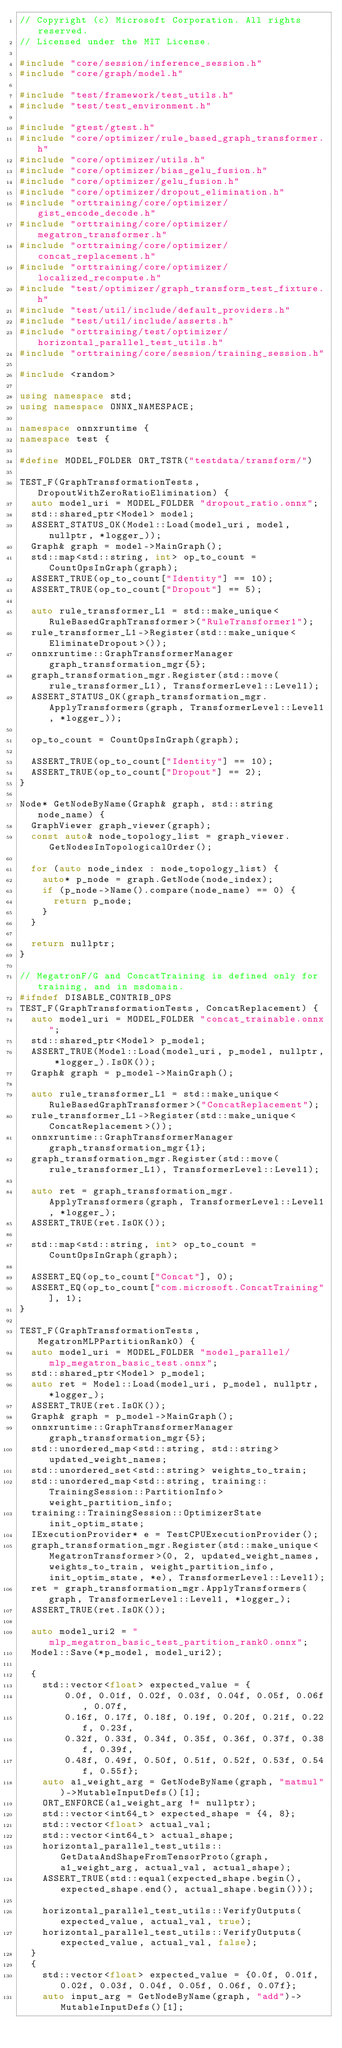<code> <loc_0><loc_0><loc_500><loc_500><_C++_>// Copyright (c) Microsoft Corporation. All rights reserved.
// Licensed under the MIT License.

#include "core/session/inference_session.h"
#include "core/graph/model.h"

#include "test/framework/test_utils.h"
#include "test/test_environment.h"

#include "gtest/gtest.h"
#include "core/optimizer/rule_based_graph_transformer.h"
#include "core/optimizer/utils.h"
#include "core/optimizer/bias_gelu_fusion.h"
#include "core/optimizer/gelu_fusion.h"
#include "core/optimizer/dropout_elimination.h"
#include "orttraining/core/optimizer/gist_encode_decode.h"
#include "orttraining/core/optimizer/megatron_transformer.h"
#include "orttraining/core/optimizer/concat_replacement.h"
#include "orttraining/core/optimizer/localized_recompute.h"
#include "test/optimizer/graph_transform_test_fixture.h"
#include "test/util/include/default_providers.h"
#include "test/util/include/asserts.h"
#include "orttraining/test/optimizer/horizontal_parallel_test_utils.h"
#include "orttraining/core/session/training_session.h"

#include <random>

using namespace std;
using namespace ONNX_NAMESPACE;

namespace onnxruntime {
namespace test {

#define MODEL_FOLDER ORT_TSTR("testdata/transform/")

TEST_F(GraphTransformationTests, DropoutWithZeroRatioElimination) {
  auto model_uri = MODEL_FOLDER "dropout_ratio.onnx";
  std::shared_ptr<Model> model;
  ASSERT_STATUS_OK(Model::Load(model_uri, model, nullptr, *logger_));
  Graph& graph = model->MainGraph();
  std::map<std::string, int> op_to_count = CountOpsInGraph(graph);
  ASSERT_TRUE(op_to_count["Identity"] == 10);
  ASSERT_TRUE(op_to_count["Dropout"] == 5);

  auto rule_transformer_L1 = std::make_unique<RuleBasedGraphTransformer>("RuleTransformer1");
  rule_transformer_L1->Register(std::make_unique<EliminateDropout>());
  onnxruntime::GraphTransformerManager graph_transformation_mgr{5};
  graph_transformation_mgr.Register(std::move(rule_transformer_L1), TransformerLevel::Level1);
  ASSERT_STATUS_OK(graph_transformation_mgr.ApplyTransformers(graph, TransformerLevel::Level1, *logger_));

  op_to_count = CountOpsInGraph(graph);

  ASSERT_TRUE(op_to_count["Identity"] == 10);
  ASSERT_TRUE(op_to_count["Dropout"] == 2);
}

Node* GetNodeByName(Graph& graph, std::string node_name) {
  GraphViewer graph_viewer(graph);
  const auto& node_topology_list = graph_viewer.GetNodesInTopologicalOrder();

  for (auto node_index : node_topology_list) {
    auto* p_node = graph.GetNode(node_index);
    if (p_node->Name().compare(node_name) == 0) {
      return p_node;
    }
  }

  return nullptr;
}

// MegatronF/G and ConcatTraining is defined only for training, and in msdomain.
#ifndef DISABLE_CONTRIB_OPS
TEST_F(GraphTransformationTests, ConcatReplacement) {
  auto model_uri = MODEL_FOLDER "concat_trainable.onnx";
  std::shared_ptr<Model> p_model;
  ASSERT_TRUE(Model::Load(model_uri, p_model, nullptr, *logger_).IsOK());
  Graph& graph = p_model->MainGraph();

  auto rule_transformer_L1 = std::make_unique<RuleBasedGraphTransformer>("ConcatReplacement");
  rule_transformer_L1->Register(std::make_unique<ConcatReplacement>());
  onnxruntime::GraphTransformerManager graph_transformation_mgr{1};
  graph_transformation_mgr.Register(std::move(rule_transformer_L1), TransformerLevel::Level1);

  auto ret = graph_transformation_mgr.ApplyTransformers(graph, TransformerLevel::Level1, *logger_);
  ASSERT_TRUE(ret.IsOK());

  std::map<std::string, int> op_to_count = CountOpsInGraph(graph);

  ASSERT_EQ(op_to_count["Concat"], 0);
  ASSERT_EQ(op_to_count["com.microsoft.ConcatTraining"], 1);
}

TEST_F(GraphTransformationTests, MegatronMLPPartitionRank0) {
  auto model_uri = MODEL_FOLDER "model_parallel/mlp_megatron_basic_test.onnx";
  std::shared_ptr<Model> p_model;
  auto ret = Model::Load(model_uri, p_model, nullptr, *logger_);
  ASSERT_TRUE(ret.IsOK());
  Graph& graph = p_model->MainGraph();
  onnxruntime::GraphTransformerManager graph_transformation_mgr{5};
  std::unordered_map<std::string, std::string> updated_weight_names;
  std::unordered_set<std::string> weights_to_train;
  std::unordered_map<std::string, training::TrainingSession::PartitionInfo> weight_partition_info;
  training::TrainingSession::OptimizerState init_optim_state;
  IExecutionProvider* e = TestCPUExecutionProvider();
  graph_transformation_mgr.Register(std::make_unique<MegatronTransformer>(0, 2, updated_weight_names, weights_to_train, weight_partition_info, init_optim_state, *e), TransformerLevel::Level1);
  ret = graph_transformation_mgr.ApplyTransformers(graph, TransformerLevel::Level1, *logger_);
  ASSERT_TRUE(ret.IsOK());

  auto model_uri2 = "mlp_megatron_basic_test_partition_rank0.onnx";
  Model::Save(*p_model, model_uri2);

  {
    std::vector<float> expected_value = {
        0.0f, 0.01f, 0.02f, 0.03f, 0.04f, 0.05f, 0.06f, 0.07f,
        0.16f, 0.17f, 0.18f, 0.19f, 0.20f, 0.21f, 0.22f, 0.23f,
        0.32f, 0.33f, 0.34f, 0.35f, 0.36f, 0.37f, 0.38f, 0.39f,
        0.48f, 0.49f, 0.50f, 0.51f, 0.52f, 0.53f, 0.54f, 0.55f};
    auto a1_weight_arg = GetNodeByName(graph, "matmul")->MutableInputDefs()[1];
    ORT_ENFORCE(a1_weight_arg != nullptr);
    std::vector<int64_t> expected_shape = {4, 8};
    std::vector<float> actual_val;
    std::vector<int64_t> actual_shape;
    horizontal_parallel_test_utils::GetDataAndShapeFromTensorProto(graph, a1_weight_arg, actual_val, actual_shape);
    ASSERT_TRUE(std::equal(expected_shape.begin(), expected_shape.end(), actual_shape.begin()));

    horizontal_parallel_test_utils::VerifyOutputs(expected_value, actual_val, true);
    horizontal_parallel_test_utils::VerifyOutputs(expected_value, actual_val, false);
  }
  {
    std::vector<float> expected_value = {0.0f, 0.01f, 0.02f, 0.03f, 0.04f, 0.05f, 0.06f, 0.07f};
    auto input_arg = GetNodeByName(graph, "add")->MutableInputDefs()[1];</code> 